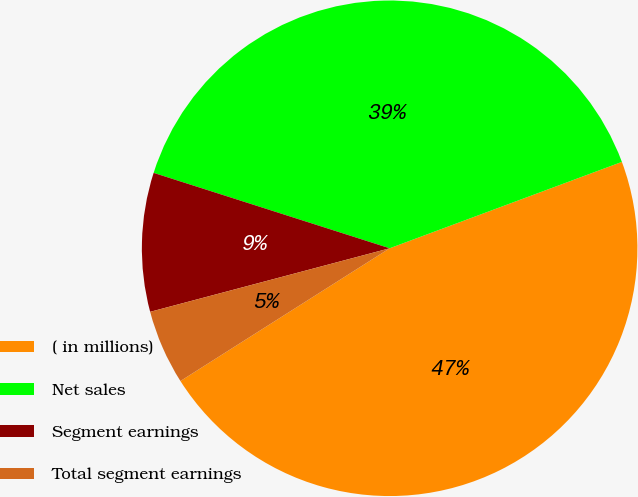Convert chart. <chart><loc_0><loc_0><loc_500><loc_500><pie_chart><fcel>( in millions)<fcel>Net sales<fcel>Segment earnings<fcel>Total segment earnings<nl><fcel>46.67%<fcel>39.41%<fcel>9.05%<fcel>4.87%<nl></chart> 